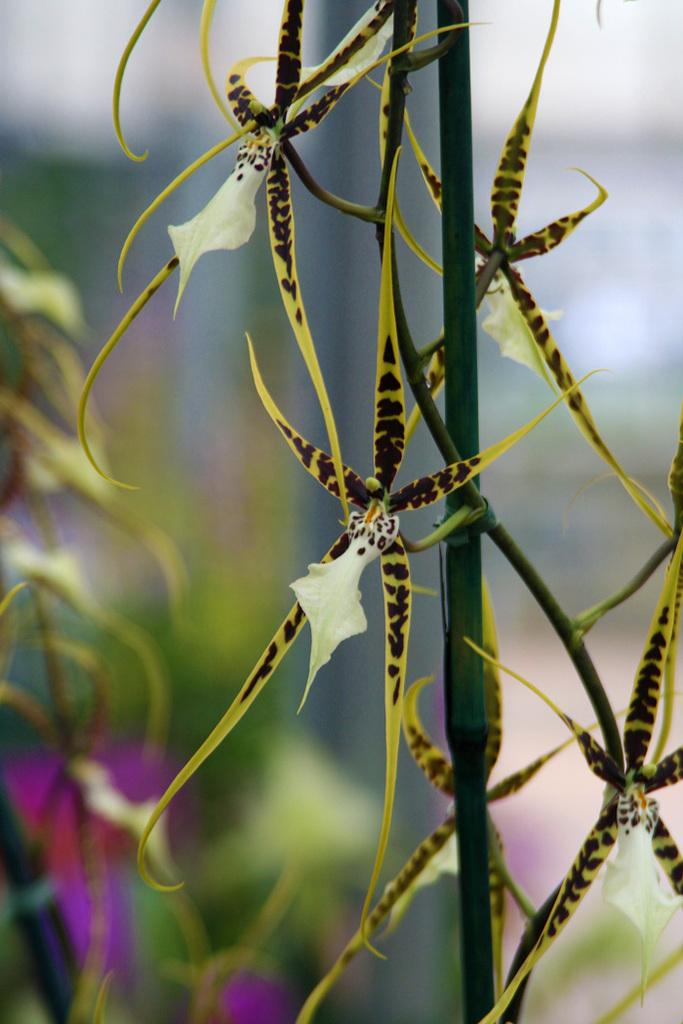What type of plant life is present in the image? There are flowers with stems in the image. Can you describe the background of the main image? There is a blurred image in the background of the main image. What can be seen in the blurred image? The blurred image contains flowers on plants. What type of truck can be seen in the image? There is no truck present in the image. How many bells are hanging from the flowers in the image? There are no bells hanging from the flowers in the image. 